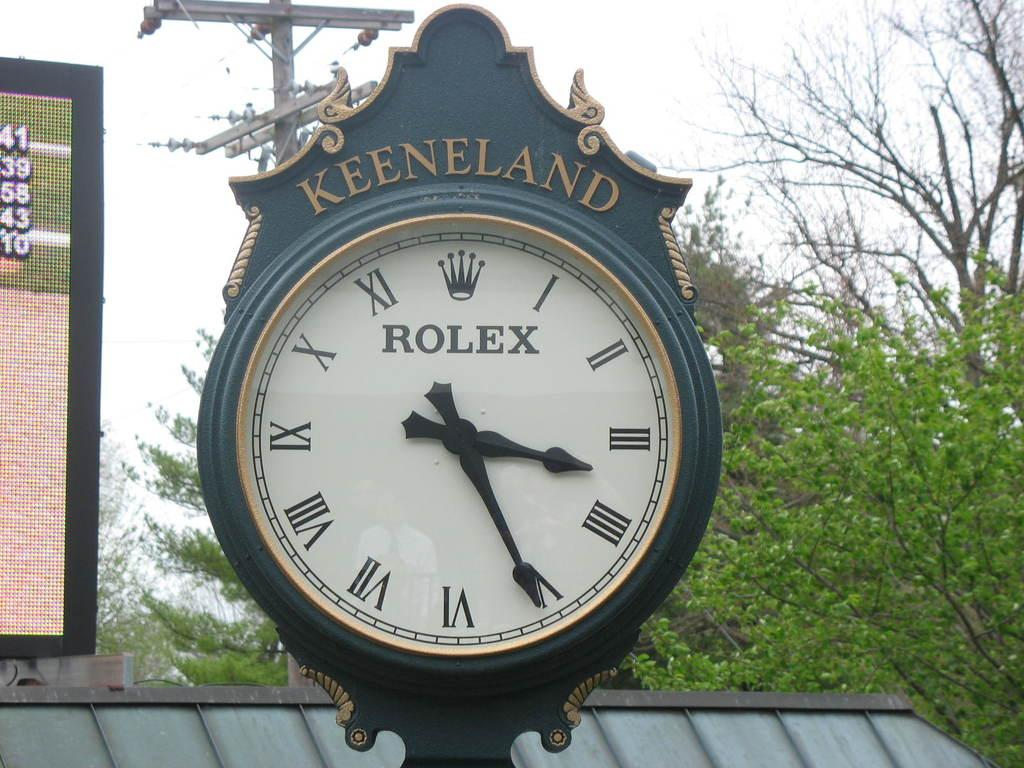<image>
Share a concise interpretation of the image provided. A Rolex clock tower that shows 3:25 o'clock. 